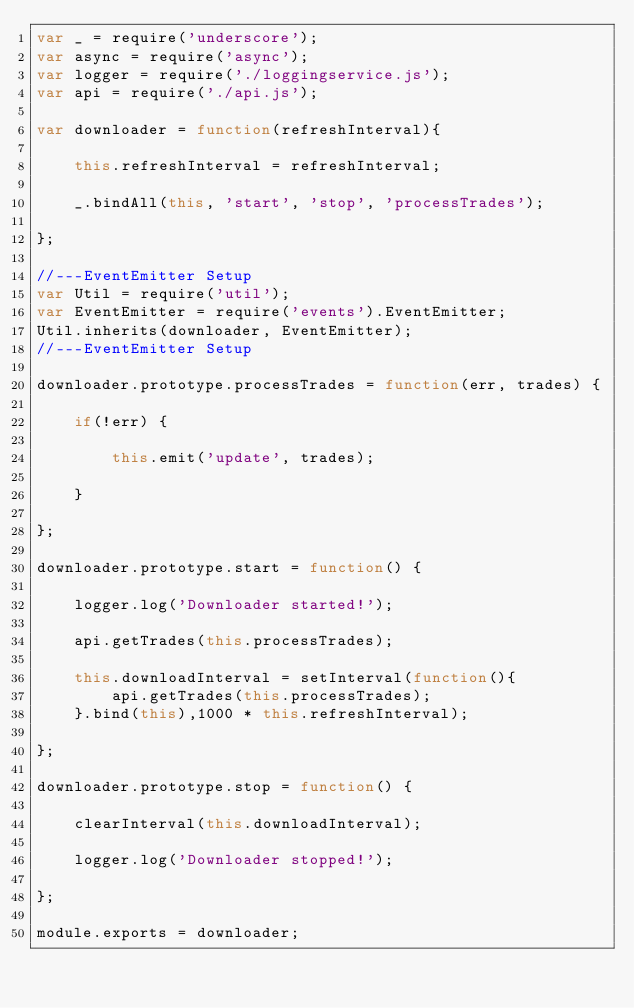<code> <loc_0><loc_0><loc_500><loc_500><_JavaScript_>var _ = require('underscore');
var async = require('async');
var logger = require('./loggingservice.js');
var api = require('./api.js');

var downloader = function(refreshInterval){

    this.refreshInterval = refreshInterval;

    _.bindAll(this, 'start', 'stop', 'processTrades');

};

//---EventEmitter Setup
var Util = require('util');
var EventEmitter = require('events').EventEmitter;
Util.inherits(downloader, EventEmitter);
//---EventEmitter Setup

downloader.prototype.processTrades = function(err, trades) {

    if(!err) {

        this.emit('update', trades);

    }

};

downloader.prototype.start = function() {

    logger.log('Downloader started!');
    
    api.getTrades(this.processTrades);
    
    this.downloadInterval = setInterval(function(){
        api.getTrades(this.processTrades);
    }.bind(this),1000 * this.refreshInterval);

};

downloader.prototype.stop = function() {

    clearInterval(this.downloadInterval);

    logger.log('Downloader stopped!');

};

module.exports = downloader;</code> 